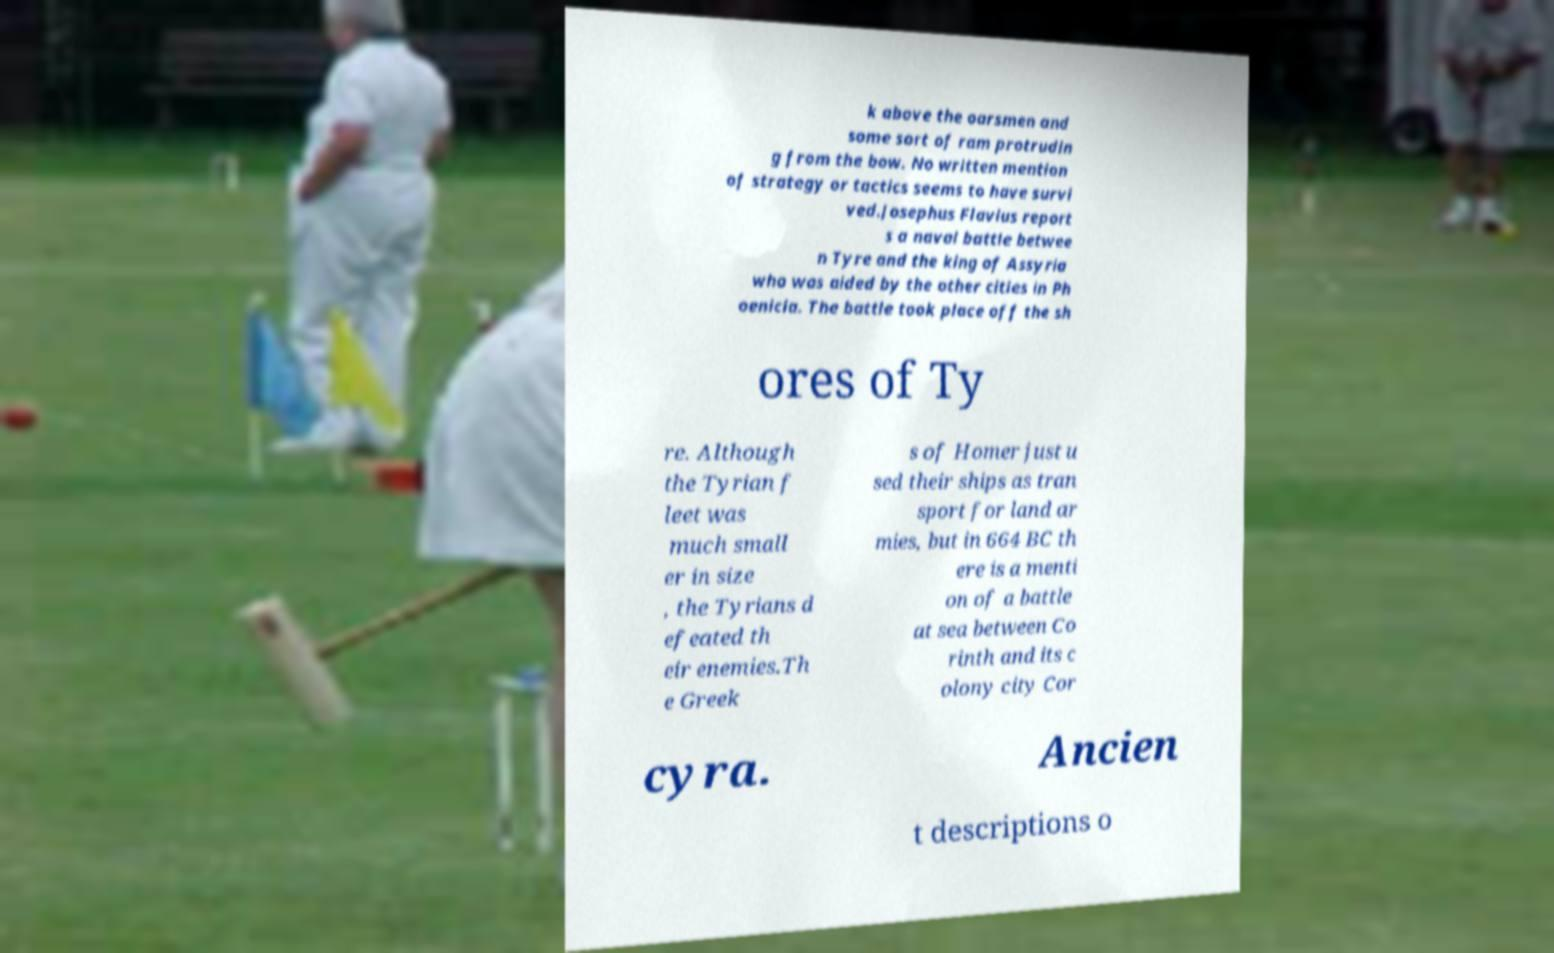I need the written content from this picture converted into text. Can you do that? k above the oarsmen and some sort of ram protrudin g from the bow. No written mention of strategy or tactics seems to have survi ved.Josephus Flavius report s a naval battle betwee n Tyre and the king of Assyria who was aided by the other cities in Ph oenicia. The battle took place off the sh ores of Ty re. Although the Tyrian f leet was much small er in size , the Tyrians d efeated th eir enemies.Th e Greek s of Homer just u sed their ships as tran sport for land ar mies, but in 664 BC th ere is a menti on of a battle at sea between Co rinth and its c olony city Cor cyra. Ancien t descriptions o 